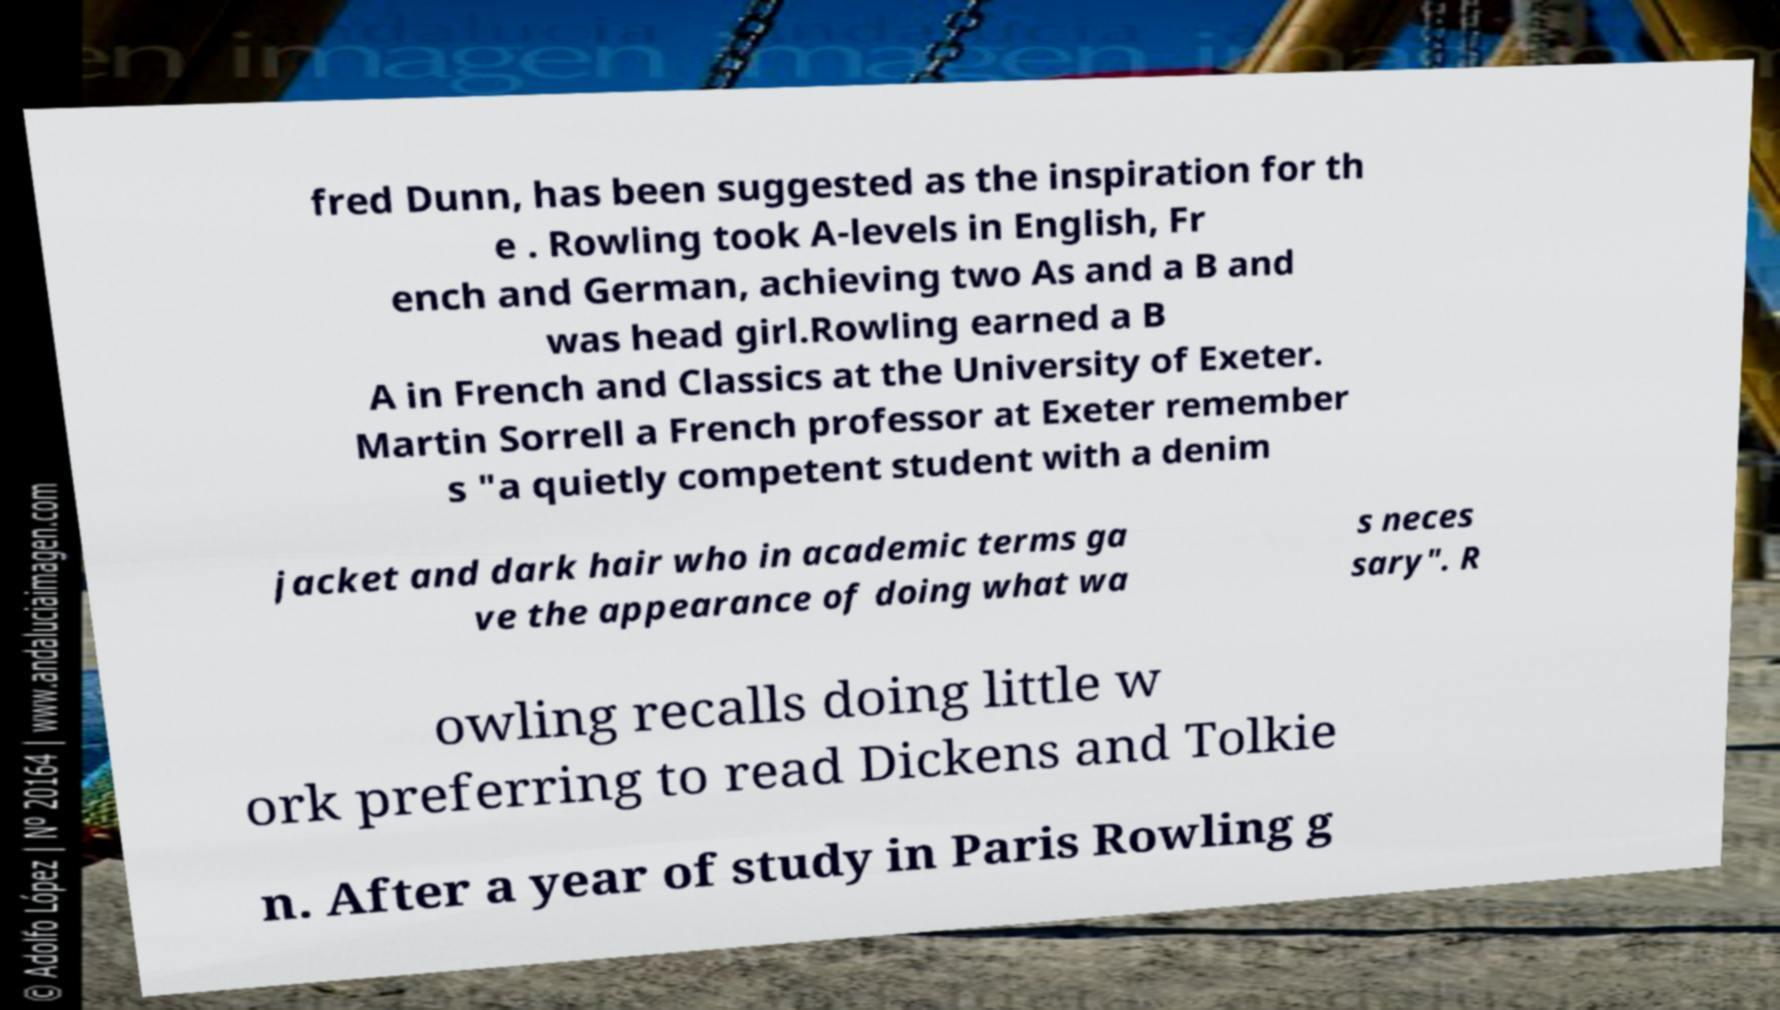Could you extract and type out the text from this image? fred Dunn, has been suggested as the inspiration for th e . Rowling took A-levels in English, Fr ench and German, achieving two As and a B and was head girl.Rowling earned a B A in French and Classics at the University of Exeter. Martin Sorrell a French professor at Exeter remember s "a quietly competent student with a denim jacket and dark hair who in academic terms ga ve the appearance of doing what wa s neces sary". R owling recalls doing little w ork preferring to read Dickens and Tolkie n. After a year of study in Paris Rowling g 